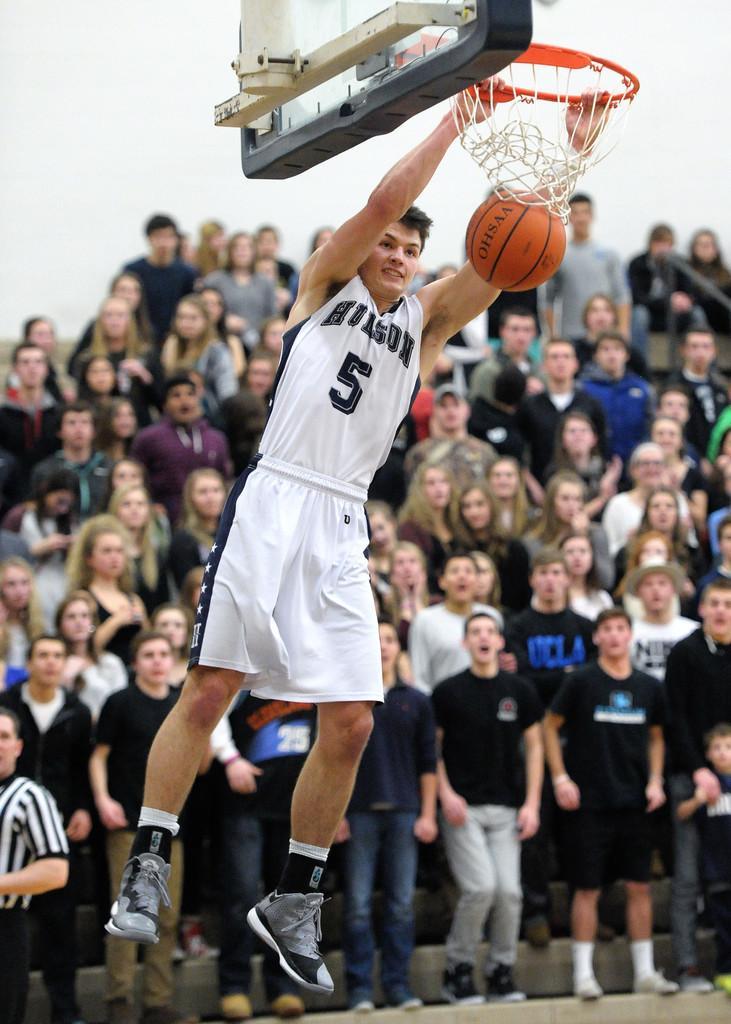Can you describe this image briefly? In this image we can see this person wearing a white dress, socks and shoes is in the air by holding the net. Here we can see the basketball in the air. The background of the image is slightly blurred, where we can see these people are standing. 